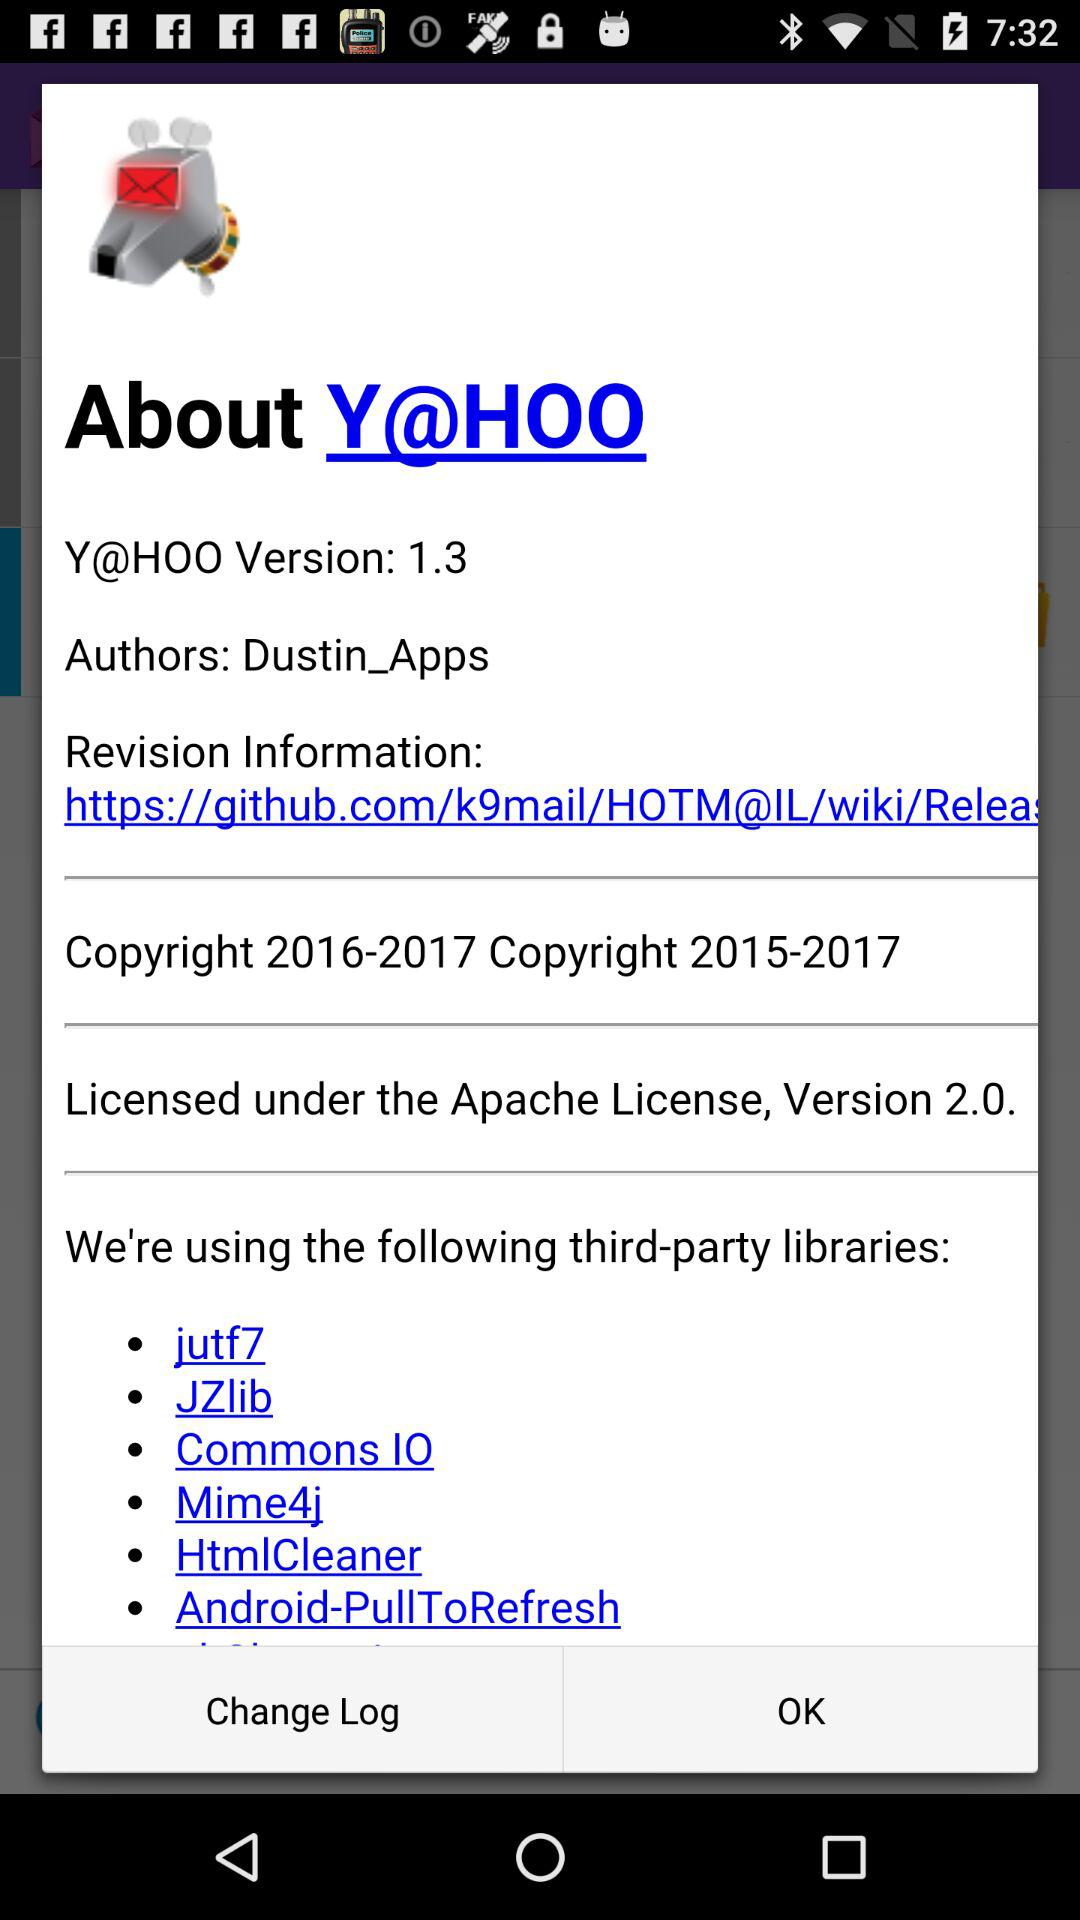What is listed in the change log?
When the provided information is insufficient, respond with <no answer>. <no answer> 